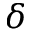Convert formula to latex. <formula><loc_0><loc_0><loc_500><loc_500>\delta</formula> 